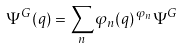Convert formula to latex. <formula><loc_0><loc_0><loc_500><loc_500>\Psi ^ { G } ( q ) = \sum _ { n } \varphi _ { n } ( q ) \, ^ { \varphi _ { n } } { \Psi ^ { G } }</formula> 